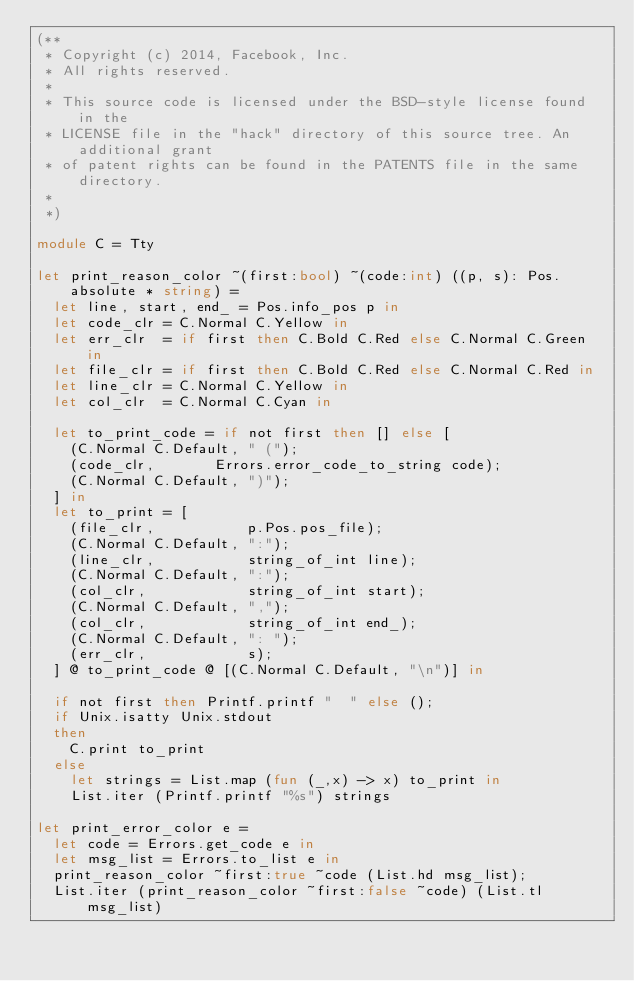<code> <loc_0><loc_0><loc_500><loc_500><_OCaml_>(**
 * Copyright (c) 2014, Facebook, Inc.
 * All rights reserved.
 *
 * This source code is licensed under the BSD-style license found in the
 * LICENSE file in the "hack" directory of this source tree. An additional grant
 * of patent rights can be found in the PATENTS file in the same directory.
 *
 *)

module C = Tty

let print_reason_color ~(first:bool) ~(code:int) ((p, s): Pos.absolute * string) =
  let line, start, end_ = Pos.info_pos p in
  let code_clr = C.Normal C.Yellow in
  let err_clr  = if first then C.Bold C.Red else C.Normal C.Green in
  let file_clr = if first then C.Bold C.Red else C.Normal C.Red in
  let line_clr = C.Normal C.Yellow in
  let col_clr  = C.Normal C.Cyan in

  let to_print_code = if not first then [] else [
    (C.Normal C.Default, " (");
    (code_clr,       Errors.error_code_to_string code);
    (C.Normal C.Default, ")");
  ] in
  let to_print = [
    (file_clr,           p.Pos.pos_file);
    (C.Normal C.Default, ":");
    (line_clr,           string_of_int line);
    (C.Normal C.Default, ":");
    (col_clr,            string_of_int start);
    (C.Normal C.Default, ",");
    (col_clr,            string_of_int end_);
    (C.Normal C.Default, ": ");
    (err_clr,            s);
  ] @ to_print_code @ [(C.Normal C.Default, "\n")] in

  if not first then Printf.printf "  " else ();
  if Unix.isatty Unix.stdout
  then
    C.print to_print
  else
    let strings = List.map (fun (_,x) -> x) to_print in
    List.iter (Printf.printf "%s") strings

let print_error_color e =
  let code = Errors.get_code e in
  let msg_list = Errors.to_list e in
  print_reason_color ~first:true ~code (List.hd msg_list);
  List.iter (print_reason_color ~first:false ~code) (List.tl msg_list)
</code> 